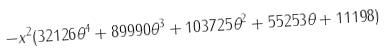<formula> <loc_0><loc_0><loc_500><loc_500>- x ^ { 2 } ( 3 2 1 2 6 \theta ^ { 4 } + 8 9 9 9 0 \theta ^ { 3 } + 1 0 3 7 2 5 \theta ^ { 2 } + 5 5 2 5 3 \theta + 1 1 1 9 8 )</formula> 